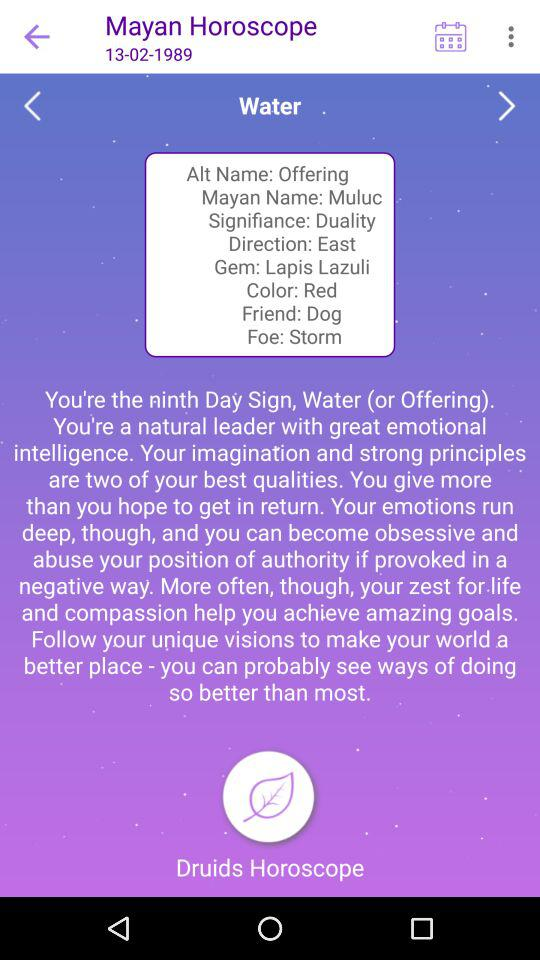What is the color? The color is "Red". 